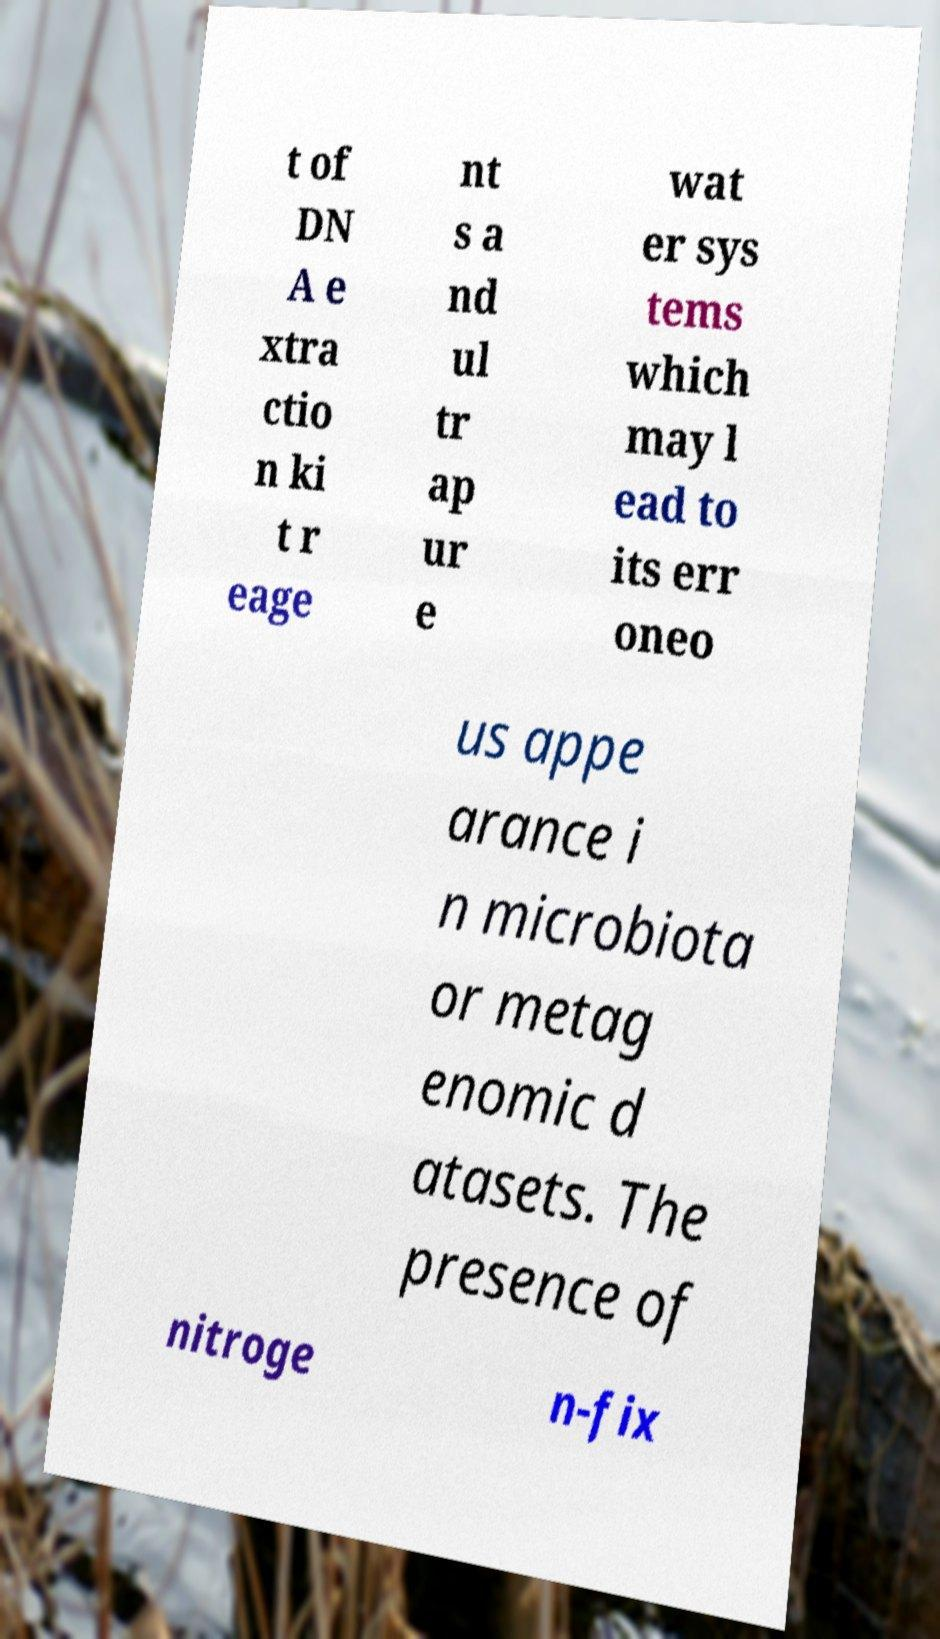Can you read and provide the text displayed in the image?This photo seems to have some interesting text. Can you extract and type it out for me? t of DN A e xtra ctio n ki t r eage nt s a nd ul tr ap ur e wat er sys tems which may l ead to its err oneo us appe arance i n microbiota or metag enomic d atasets. The presence of nitroge n-fix 